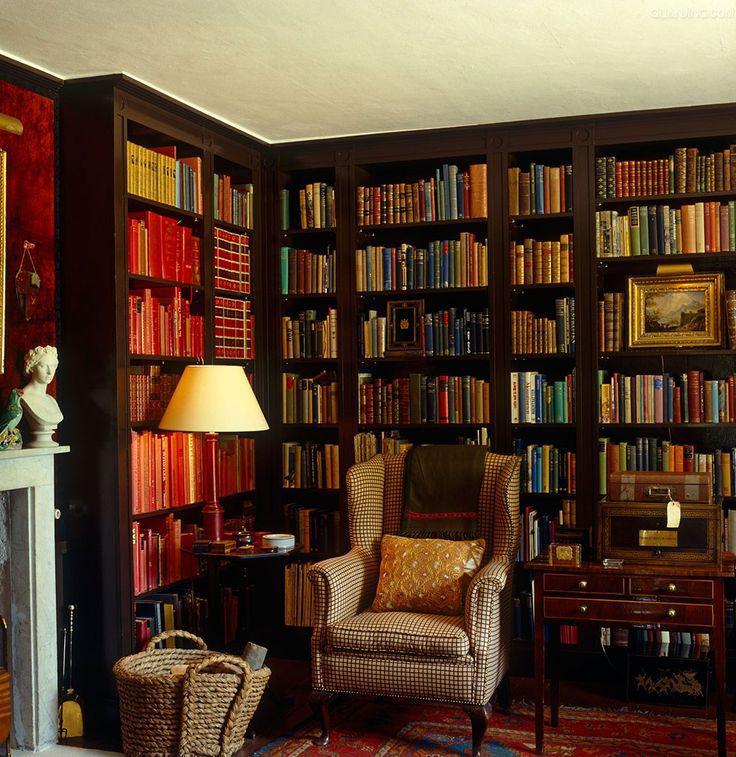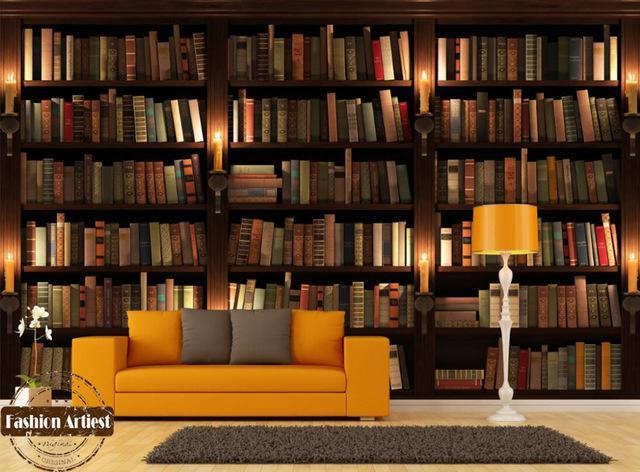The first image is the image on the left, the second image is the image on the right. Assess this claim about the two images: "There are at most three picture frames.". Correct or not? Answer yes or no. Yes. 